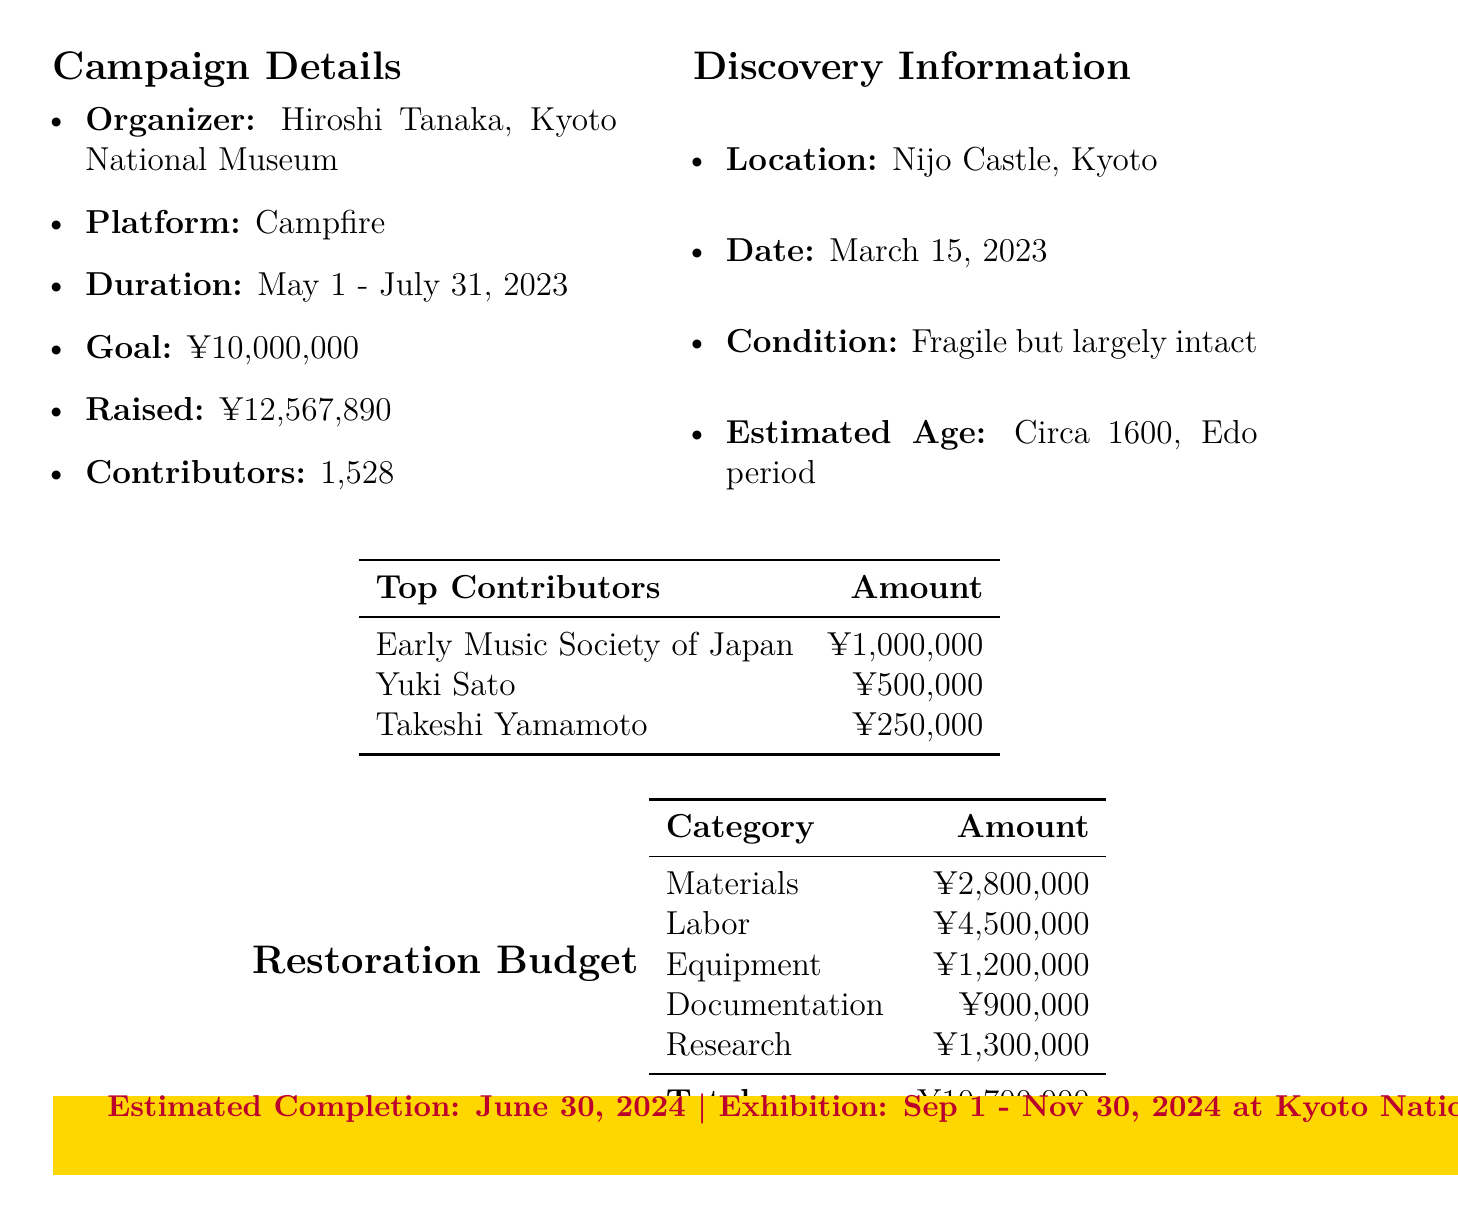What is the campaign's funding goal? The funding goal is stated clearly in the document, which specifies the amount targeted for the campaign.
Answer: ¥10,000,000 Who organized the campaign? The document names the campaign organizer, providing a clear indication of who is responsible for the crowdfunding effort.
Answer: Hiroshi Tanaka, Kyoto National Museum What is the total amount raised in the campaign? The document specifies the total amount raised by the campaign, which is crucial information regarding its success.
Answer: ¥12,567,890 What is the name of the master luthier involved in the restoration? The document lists the individuals involved in the restoration, including their roles and affiliations.
Answer: Masaru Ito How many contributors participated in the campaign? The document quantifies the number of contributors, indicating the level of community support for the project.
Answer: 1528 What is the estimated completion date for the restoration? The document clearly indicates when the restoration work is expected to be finished, which is vital for planning future activities.
Answer: June 30, 2024 What special event is planned during the exhibition? The document mentions specific events planned as part of the exhibition to attract interest and participation.
Answer: Lute performance by Junko Koyanagi What is the budget allocated for materials? The restoration budget in the document breaks down costs by category, providing specific figures for materials used in restoration.
Answer: ¥2,800,000 Which location was the lute discovered? The document specifies the discovery location, which is significant for historical context.
Answer: Nijo Castle, Kyoto 